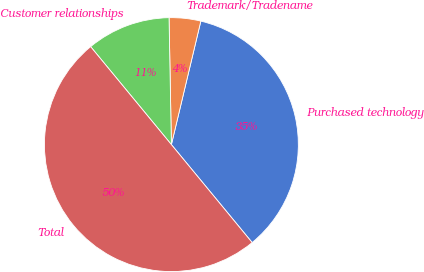<chart> <loc_0><loc_0><loc_500><loc_500><pie_chart><fcel>Purchased technology<fcel>Trademark/Tradename<fcel>Customer relationships<fcel>Total<nl><fcel>35.3%<fcel>4.02%<fcel>10.68%<fcel>50.0%<nl></chart> 